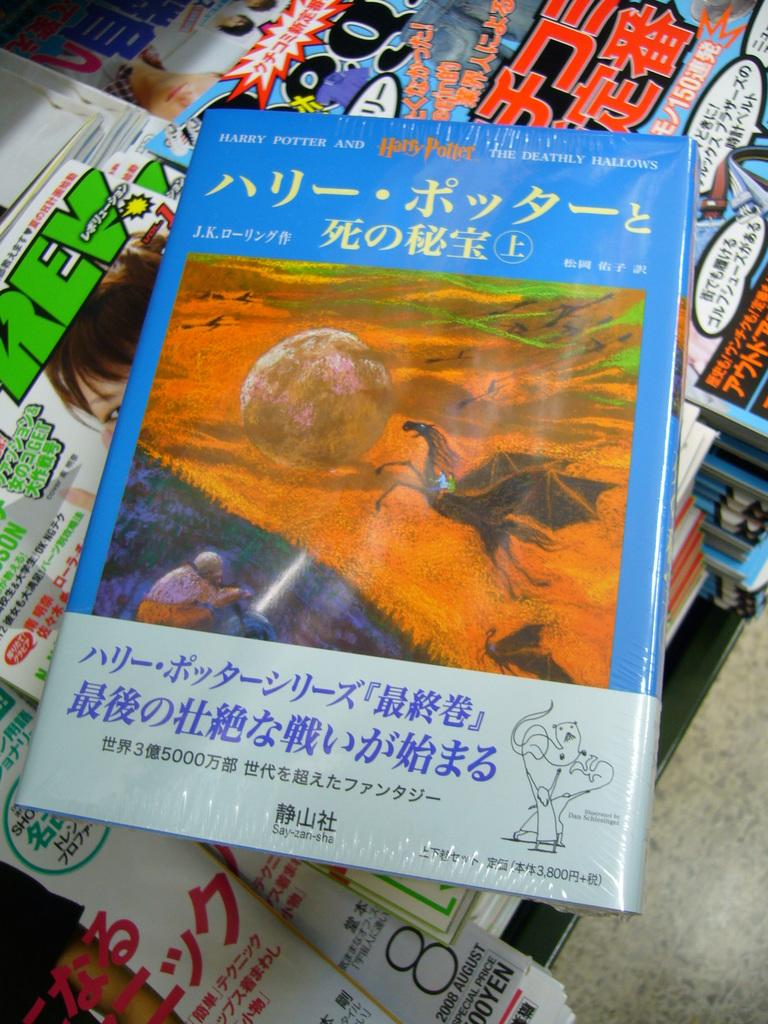<image>
Describe the image concisely. A foreign language translation of Harry Potter and the Deathly Hallows. 